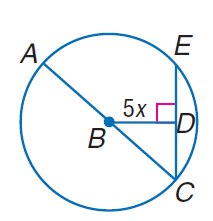Answer the mathemtical geometry problem and directly provide the correct option letter.
Question: In \odot B, the diameter is 20 units long, and m \angle A C E = 45. Find x.
Choices: A: \sqrt { 2 } B: 2 C: 4 D: 5 \sqrt { 2 } A 